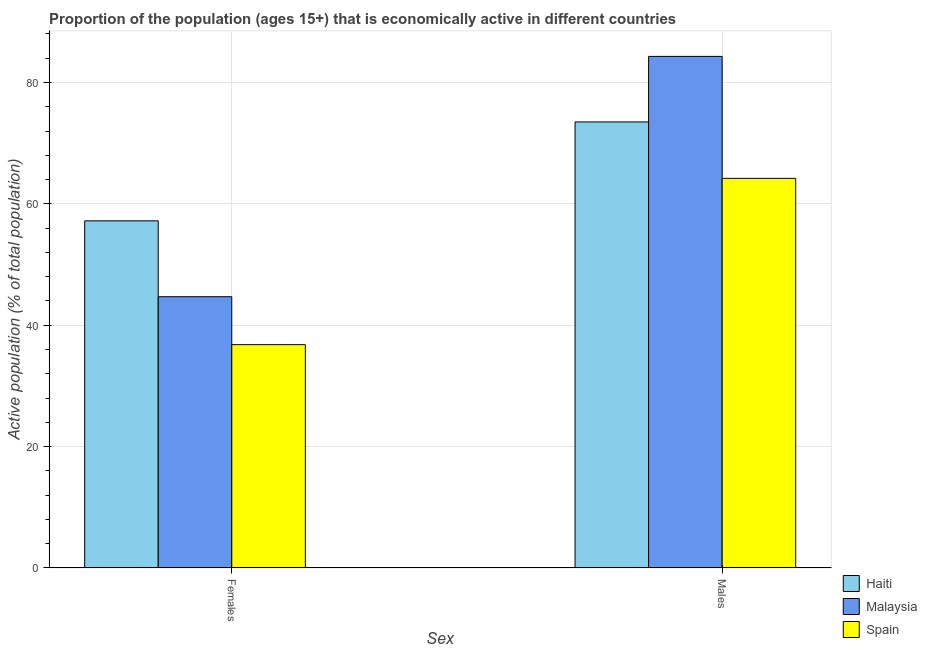How many groups of bars are there?
Your answer should be compact. 2. Are the number of bars per tick equal to the number of legend labels?
Keep it short and to the point. Yes. What is the label of the 2nd group of bars from the left?
Offer a very short reply. Males. What is the percentage of economically active male population in Malaysia?
Provide a succinct answer. 84.3. Across all countries, what is the maximum percentage of economically active female population?
Give a very brief answer. 57.2. Across all countries, what is the minimum percentage of economically active male population?
Your answer should be compact. 64.2. In which country was the percentage of economically active male population maximum?
Offer a very short reply. Malaysia. In which country was the percentage of economically active male population minimum?
Your response must be concise. Spain. What is the total percentage of economically active female population in the graph?
Provide a succinct answer. 138.7. What is the difference between the percentage of economically active male population in Malaysia and that in Haiti?
Make the answer very short. 10.8. What is the difference between the percentage of economically active male population in Haiti and the percentage of economically active female population in Spain?
Provide a short and direct response. 36.7. What is the average percentage of economically active male population per country?
Give a very brief answer. 74. What is the difference between the percentage of economically active male population and percentage of economically active female population in Spain?
Ensure brevity in your answer.  27.4. In how many countries, is the percentage of economically active male population greater than 36 %?
Ensure brevity in your answer.  3. What is the ratio of the percentage of economically active female population in Spain to that in Haiti?
Provide a short and direct response. 0.64. What does the 2nd bar from the left in Females represents?
Your answer should be compact. Malaysia. What does the 2nd bar from the right in Females represents?
Offer a terse response. Malaysia. How many bars are there?
Ensure brevity in your answer.  6. Are all the bars in the graph horizontal?
Your answer should be very brief. No. How many countries are there in the graph?
Your answer should be compact. 3. Are the values on the major ticks of Y-axis written in scientific E-notation?
Make the answer very short. No. How many legend labels are there?
Your answer should be compact. 3. How are the legend labels stacked?
Provide a short and direct response. Vertical. What is the title of the graph?
Make the answer very short. Proportion of the population (ages 15+) that is economically active in different countries. What is the label or title of the X-axis?
Your answer should be very brief. Sex. What is the label or title of the Y-axis?
Offer a terse response. Active population (% of total population). What is the Active population (% of total population) of Haiti in Females?
Provide a succinct answer. 57.2. What is the Active population (% of total population) of Malaysia in Females?
Your answer should be compact. 44.7. What is the Active population (% of total population) in Spain in Females?
Keep it short and to the point. 36.8. What is the Active population (% of total population) of Haiti in Males?
Your response must be concise. 73.5. What is the Active population (% of total population) in Malaysia in Males?
Your response must be concise. 84.3. What is the Active population (% of total population) in Spain in Males?
Offer a terse response. 64.2. Across all Sex, what is the maximum Active population (% of total population) in Haiti?
Your answer should be very brief. 73.5. Across all Sex, what is the maximum Active population (% of total population) in Malaysia?
Your answer should be very brief. 84.3. Across all Sex, what is the maximum Active population (% of total population) of Spain?
Make the answer very short. 64.2. Across all Sex, what is the minimum Active population (% of total population) of Haiti?
Your answer should be very brief. 57.2. Across all Sex, what is the minimum Active population (% of total population) in Malaysia?
Your answer should be very brief. 44.7. Across all Sex, what is the minimum Active population (% of total population) in Spain?
Provide a succinct answer. 36.8. What is the total Active population (% of total population) of Haiti in the graph?
Make the answer very short. 130.7. What is the total Active population (% of total population) of Malaysia in the graph?
Provide a succinct answer. 129. What is the total Active population (% of total population) in Spain in the graph?
Your answer should be compact. 101. What is the difference between the Active population (% of total population) in Haiti in Females and that in Males?
Your response must be concise. -16.3. What is the difference between the Active population (% of total population) in Malaysia in Females and that in Males?
Provide a succinct answer. -39.6. What is the difference between the Active population (% of total population) of Spain in Females and that in Males?
Your answer should be compact. -27.4. What is the difference between the Active population (% of total population) of Haiti in Females and the Active population (% of total population) of Malaysia in Males?
Your answer should be very brief. -27.1. What is the difference between the Active population (% of total population) in Haiti in Females and the Active population (% of total population) in Spain in Males?
Provide a short and direct response. -7. What is the difference between the Active population (% of total population) in Malaysia in Females and the Active population (% of total population) in Spain in Males?
Offer a terse response. -19.5. What is the average Active population (% of total population) of Haiti per Sex?
Ensure brevity in your answer.  65.35. What is the average Active population (% of total population) in Malaysia per Sex?
Keep it short and to the point. 64.5. What is the average Active population (% of total population) of Spain per Sex?
Your answer should be compact. 50.5. What is the difference between the Active population (% of total population) in Haiti and Active population (% of total population) in Spain in Females?
Give a very brief answer. 20.4. What is the difference between the Active population (% of total population) of Malaysia and Active population (% of total population) of Spain in Females?
Provide a succinct answer. 7.9. What is the difference between the Active population (% of total population) of Malaysia and Active population (% of total population) of Spain in Males?
Keep it short and to the point. 20.1. What is the ratio of the Active population (% of total population) of Haiti in Females to that in Males?
Your answer should be compact. 0.78. What is the ratio of the Active population (% of total population) of Malaysia in Females to that in Males?
Keep it short and to the point. 0.53. What is the ratio of the Active population (% of total population) of Spain in Females to that in Males?
Your response must be concise. 0.57. What is the difference between the highest and the second highest Active population (% of total population) in Malaysia?
Offer a terse response. 39.6. What is the difference between the highest and the second highest Active population (% of total population) in Spain?
Ensure brevity in your answer.  27.4. What is the difference between the highest and the lowest Active population (% of total population) in Haiti?
Offer a very short reply. 16.3. What is the difference between the highest and the lowest Active population (% of total population) of Malaysia?
Keep it short and to the point. 39.6. What is the difference between the highest and the lowest Active population (% of total population) of Spain?
Provide a succinct answer. 27.4. 